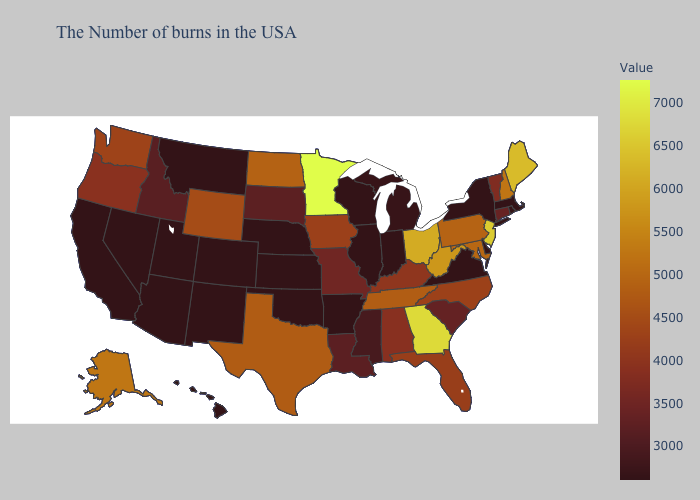Among the states that border Washington , which have the highest value?
Keep it brief. Oregon. Among the states that border California , which have the highest value?
Give a very brief answer. Oregon. Which states hav the highest value in the Northeast?
Keep it brief. New Jersey. Does New York have the lowest value in the USA?
Keep it brief. Yes. Among the states that border Minnesota , does Wisconsin have the highest value?
Short answer required. No. 